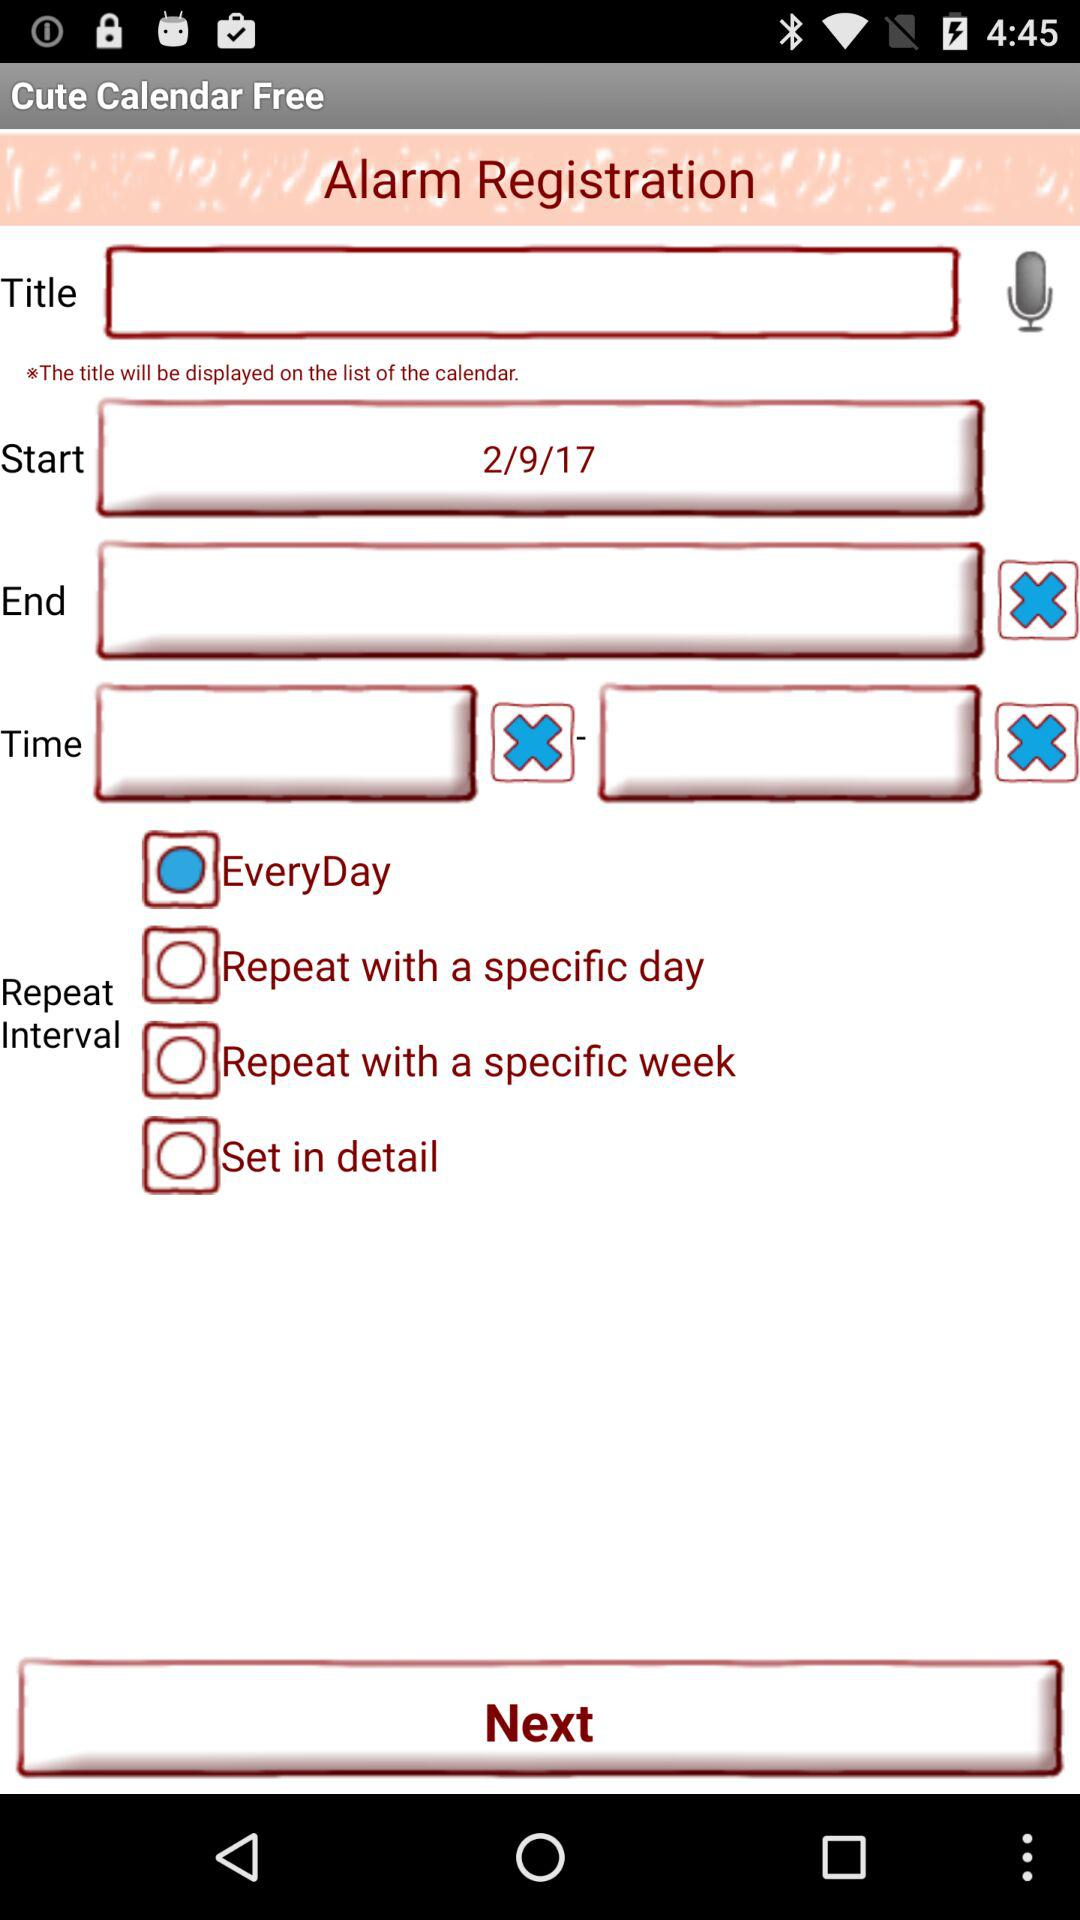When is the end date for the alarm?
When the provided information is insufficient, respond with <no answer>. <no answer> 